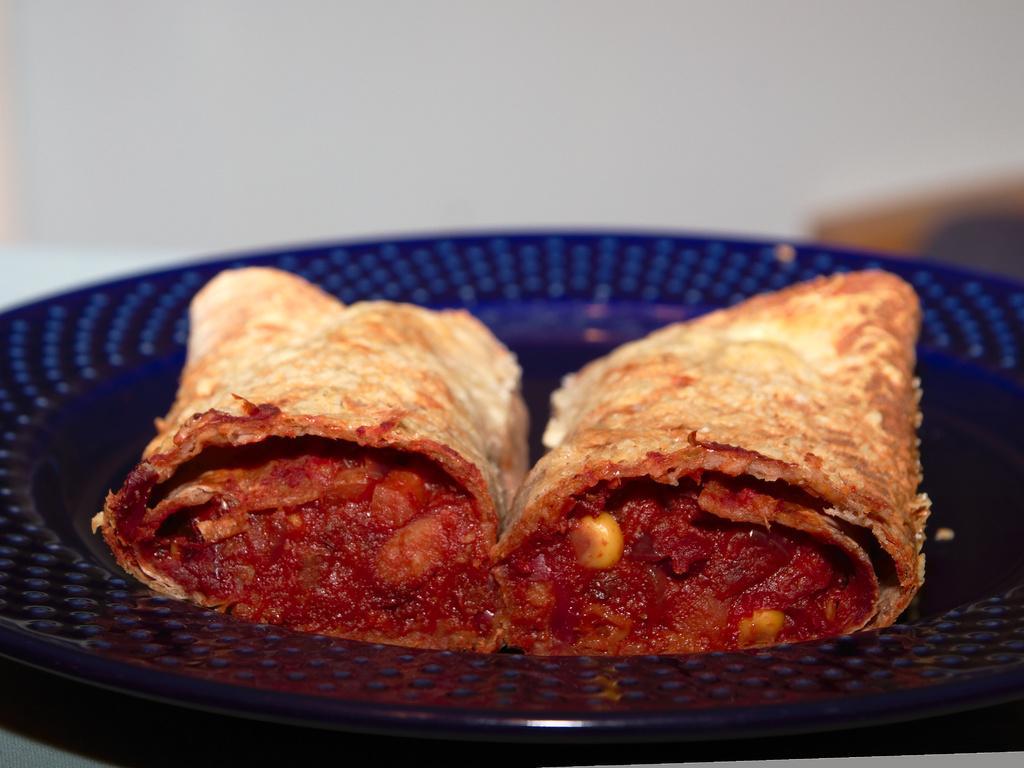In one or two sentences, can you explain what this image depicts? In this image I can see a blue colour plate and on it I can see food. I can also see this image is little bit blurry in the background. 